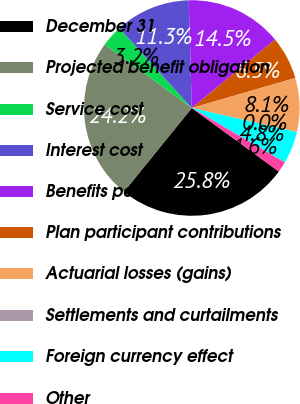Convert chart. <chart><loc_0><loc_0><loc_500><loc_500><pie_chart><fcel>December 31<fcel>Projected benefit obligation<fcel>Service cost<fcel>Interest cost<fcel>Benefits paid<fcel>Plan participant contributions<fcel>Actuarial losses (gains)<fcel>Settlements and curtailments<fcel>Foreign currency effect<fcel>Other<nl><fcel>25.8%<fcel>24.19%<fcel>3.23%<fcel>11.29%<fcel>14.51%<fcel>6.45%<fcel>8.07%<fcel>0.0%<fcel>4.84%<fcel>1.62%<nl></chart> 